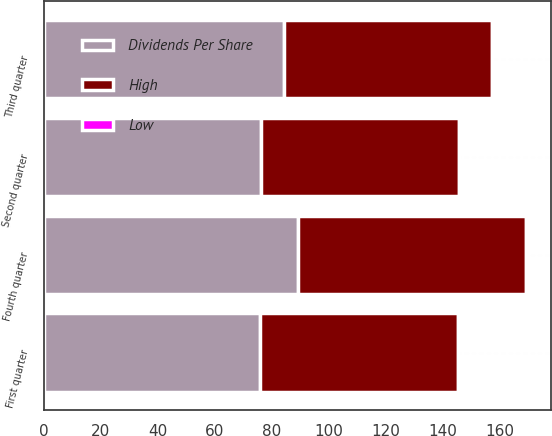Convert chart. <chart><loc_0><loc_0><loc_500><loc_500><stacked_bar_chart><ecel><fcel>First quarter<fcel>Second quarter<fcel>Third quarter<fcel>Fourth quarter<nl><fcel>Dividends Per Share<fcel>75.97<fcel>76.09<fcel>84.35<fcel>89.22<nl><fcel>High<fcel>69.11<fcel>69.61<fcel>72.9<fcel>80.04<nl><fcel>Low<fcel>0.02<fcel>0.03<fcel>0.03<fcel>0.03<nl></chart> 